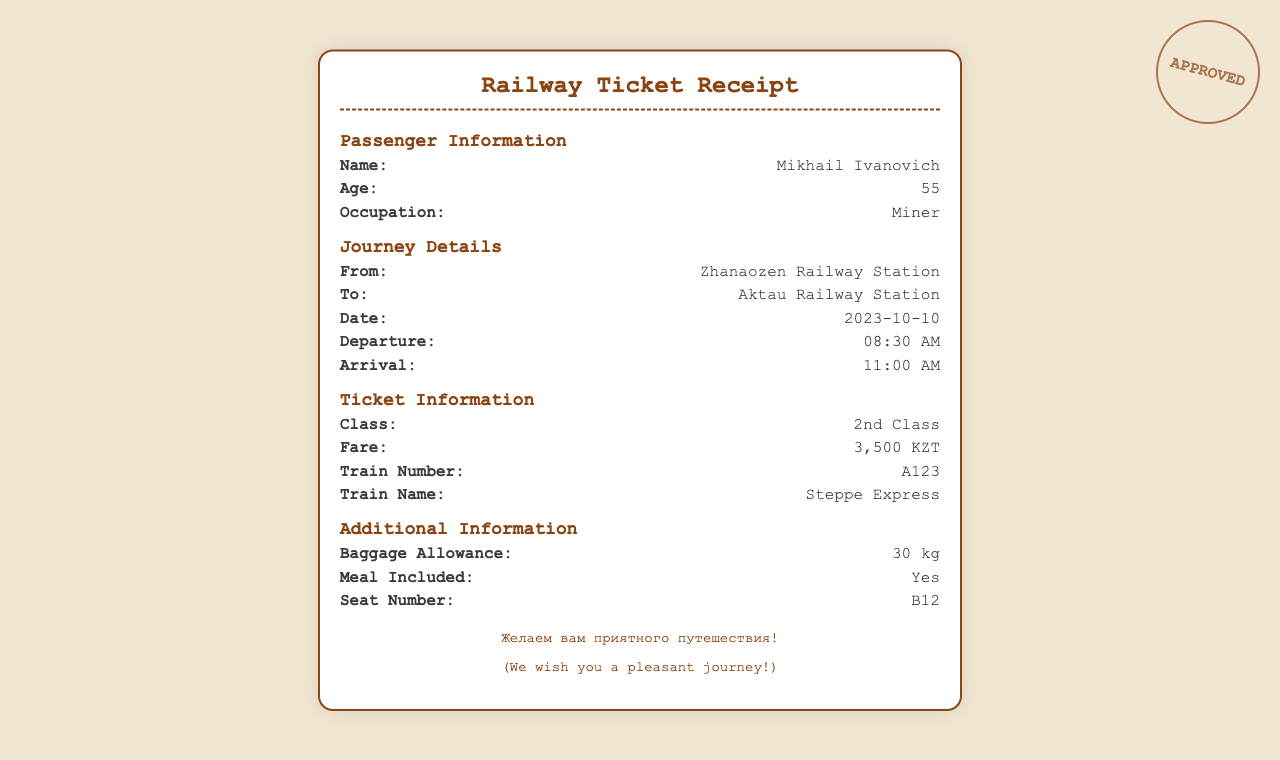What is the passenger's name? The name of the passenger is explicitly stated in the document under "Passenger Information."
Answer: Mikhail Ivanovich What is the departure time of the train? The departure time is listed in the "Journey Details" section of the document.
Answer: 08:30 AM What is the fare for the ticket? The fare amount is provided in the "Ticket Information" section.
Answer: 3,500 KZT Which class is the ticket for? The class of the ticket is mentioned in the "Ticket Information" section.
Answer: 2nd Class What is the train number? The train number can be found in the "Ticket Information" section of the document.
Answer: A123 What baggage allowance is provided? The baggage allowance is specified in the "Additional Information" section.
Answer: 30 kg What is the train name? The train name is explicitly stated in the "Ticket Information" section.
Answer: Steppe Express What time does the train arrive? The arrival time is mentioned in the "Journey Details" section.
Answer: 11:00 AM How many meals are included? The inclusion of meals is stated in the "Additional Information" section.
Answer: Yes 